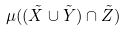<formula> <loc_0><loc_0><loc_500><loc_500>\mu ( ( \tilde { X } \cup \tilde { Y } ) \cap \tilde { Z } )</formula> 